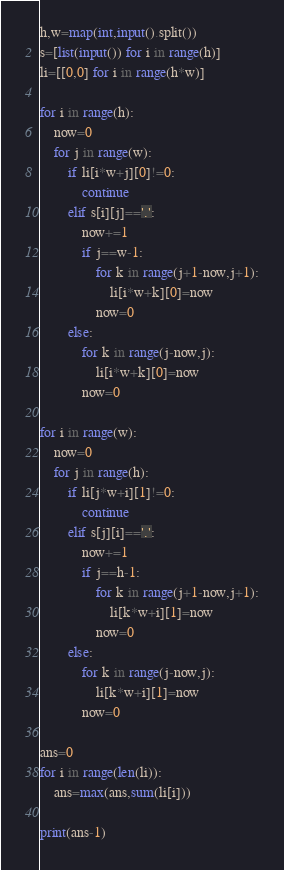<code> <loc_0><loc_0><loc_500><loc_500><_Python_>h,w=map(int,input().split())
s=[list(input()) for i in range(h)]
li=[[0,0] for i in range(h*w)]

for i in range(h):
    now=0
    for j in range(w):
        if li[i*w+j][0]!=0:
            continue
        elif s[i][j]=='.':
            now+=1
            if j==w-1:
                for k in range(j+1-now,j+1):
                    li[i*w+k][0]=now
                now=0
        else:
            for k in range(j-now,j):
                li[i*w+k][0]=now
            now=0

for i in range(w):
    now=0
    for j in range(h):
        if li[j*w+i][1]!=0:
            continue
        elif s[j][i]=='.':
            now+=1
            if j==h-1:
                for k in range(j+1-now,j+1):
                    li[k*w+i][1]=now
                now=0
        else:
            for k in range(j-now,j):
                li[k*w+i][1]=now
            now=0
    
ans=0    
for i in range(len(li)):
    ans=max(ans,sum(li[i]))
    
print(ans-1)
</code> 